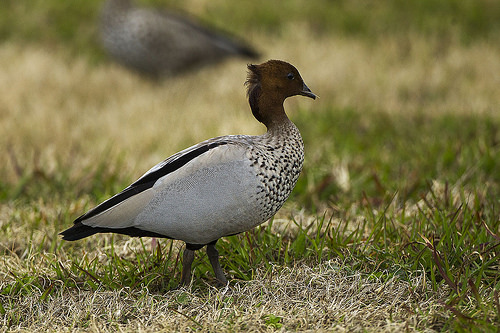<image>
Can you confirm if the bird is in front of the grass? No. The bird is not in front of the grass. The spatial positioning shows a different relationship between these objects. 